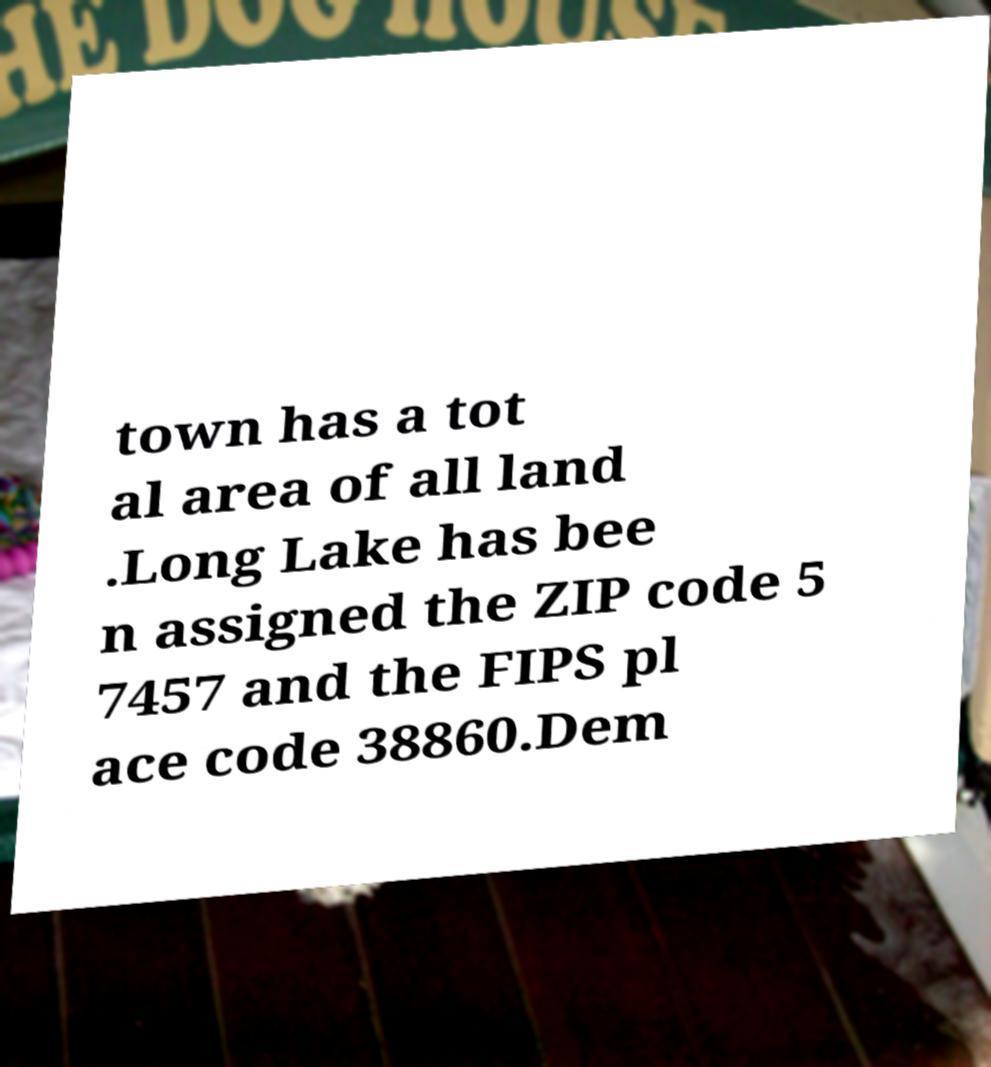For documentation purposes, I need the text within this image transcribed. Could you provide that? town has a tot al area of all land .Long Lake has bee n assigned the ZIP code 5 7457 and the FIPS pl ace code 38860.Dem 